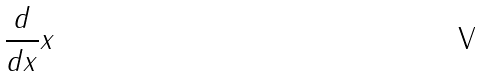<formula> <loc_0><loc_0><loc_500><loc_500>\frac { d } { d x } x</formula> 